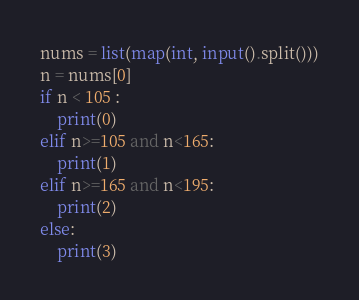<code> <loc_0><loc_0><loc_500><loc_500><_Python_>nums = list(map(int, input().split()))
n = nums[0]
if n < 105 :
    print(0)
elif n>=105 and n<165:
    print(1)
elif n>=165 and n<195:
    print(2)
else:
    print(3)</code> 